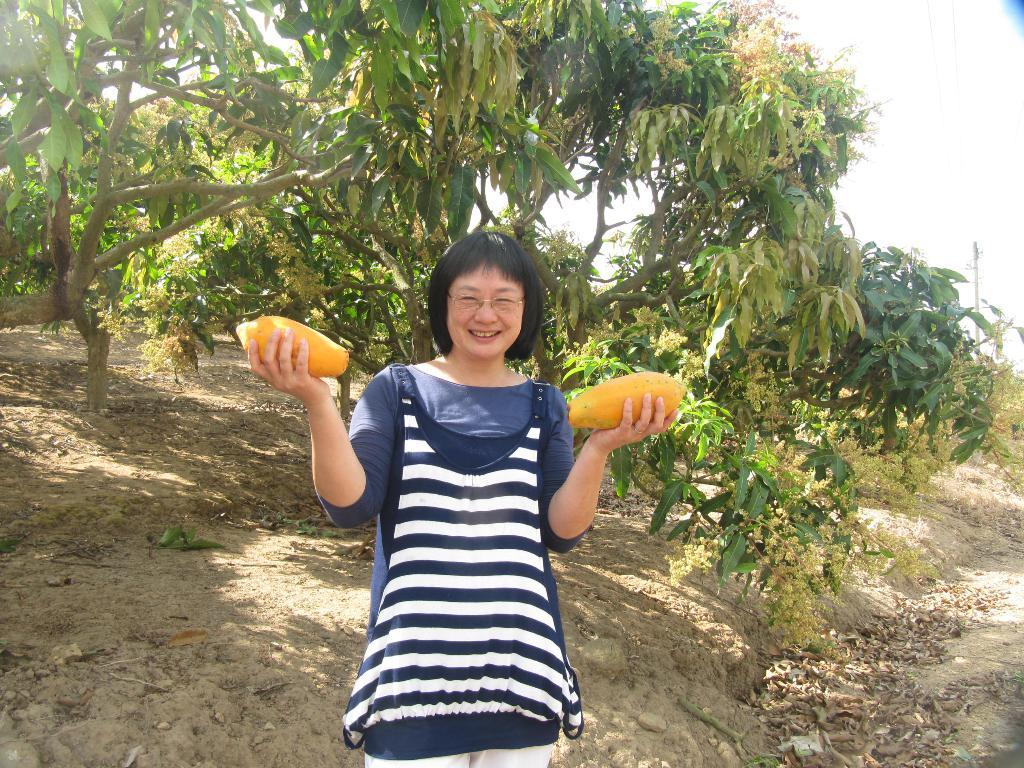What is the person in the image doing? The person is standing in the image and smiling. What is the person holding in the image? The person is holding two fruits. What can be seen in the background of the image? There are trees and the sky visible in the background of the image. Can you see a nest in the trees in the image? There is no nest visible in the trees in the image. What type of bun is the person holding in the image? The person is not holding a bun in the image; they are holding two fruits. 